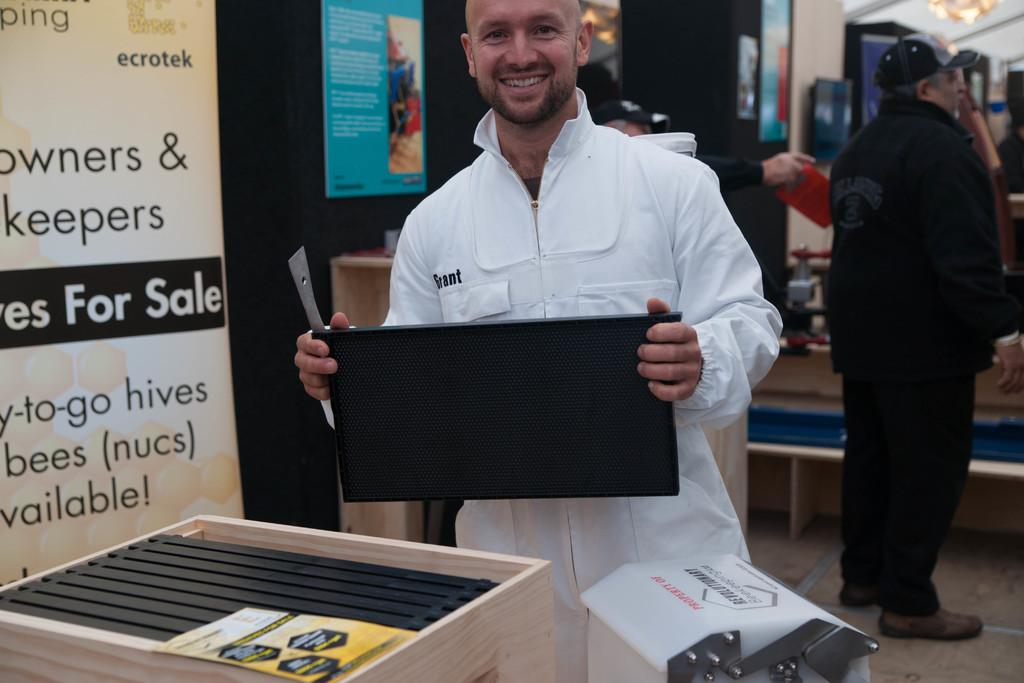Who is the main subject in the middle of the image? There is a man in the middle of the image. What is the man in the middle wearing? The man in the middle is wearing a white dress. Who is the other person in the image? There is another man on the right side of the image. What is the man on the right side wearing? The man on the right side is wearing a black dress. What type of wing can be seen on the man in the image? There are no wings visible on either man in the image. What day of the week is depicted in the image? The image does not depict a specific day of the week; it only shows two men wearing different colored dresses. 